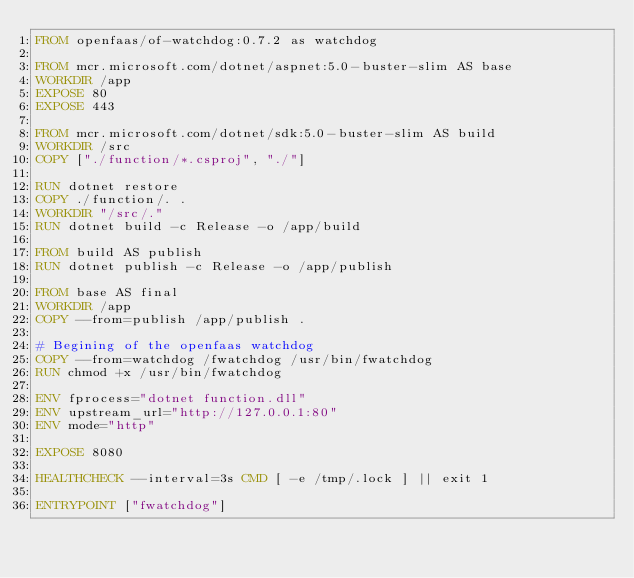<code> <loc_0><loc_0><loc_500><loc_500><_Dockerfile_>FROM openfaas/of-watchdog:0.7.2 as watchdog

FROM mcr.microsoft.com/dotnet/aspnet:5.0-buster-slim AS base
WORKDIR /app
EXPOSE 80
EXPOSE 443

FROM mcr.microsoft.com/dotnet/sdk:5.0-buster-slim AS build
WORKDIR /src
COPY ["./function/*.csproj", "./"]

RUN dotnet restore
COPY ./function/. .
WORKDIR "/src/."
RUN dotnet build -c Release -o /app/build

FROM build AS publish
RUN dotnet publish -c Release -o /app/publish

FROM base AS final
WORKDIR /app
COPY --from=publish /app/publish .

# Begining of the openfaas watchdog 
COPY --from=watchdog /fwatchdog /usr/bin/fwatchdog
RUN chmod +x /usr/bin/fwatchdog

ENV fprocess="dotnet function.dll"
ENV upstream_url="http://127.0.0.1:80"
ENV mode="http"

EXPOSE 8080

HEALTHCHECK --interval=3s CMD [ -e /tmp/.lock ] || exit 1

ENTRYPOINT ["fwatchdog"]</code> 